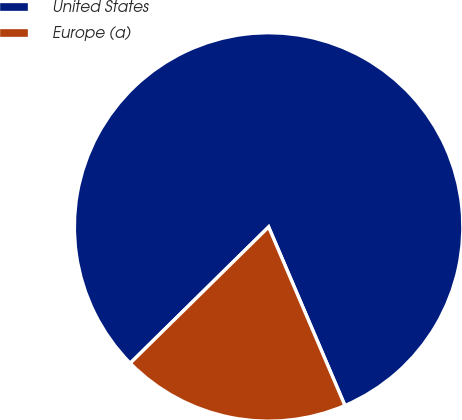Convert chart. <chart><loc_0><loc_0><loc_500><loc_500><pie_chart><fcel>United States<fcel>Europe (a)<nl><fcel>80.95%<fcel>19.05%<nl></chart> 